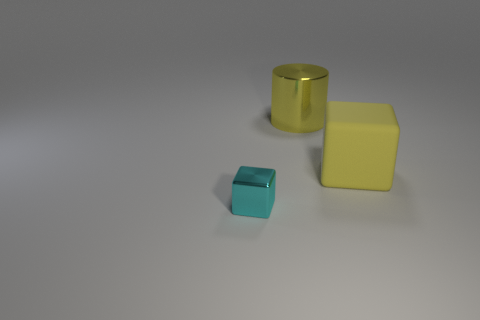How many other things are there of the same shape as the cyan metal object?
Provide a short and direct response. 1. The other thing that is the same material as the cyan thing is what shape?
Your answer should be compact. Cylinder. Is there a tiny cyan cube?
Make the answer very short. Yes. Are there fewer yellow matte blocks that are on the right side of the large yellow rubber thing than big rubber blocks that are left of the big metallic cylinder?
Offer a very short reply. No. The large object that is behind the big yellow rubber block has what shape?
Provide a succinct answer. Cylinder. Is the tiny object made of the same material as the yellow cylinder?
Give a very brief answer. Yes. Is there any other thing that is made of the same material as the yellow block?
Give a very brief answer. No. What is the material of the other object that is the same shape as the rubber thing?
Give a very brief answer. Metal. Is the number of large yellow rubber cubes that are on the left side of the tiny shiny cube less than the number of objects?
Give a very brief answer. Yes. What number of large yellow cubes are right of the yellow matte object?
Provide a succinct answer. 0. 